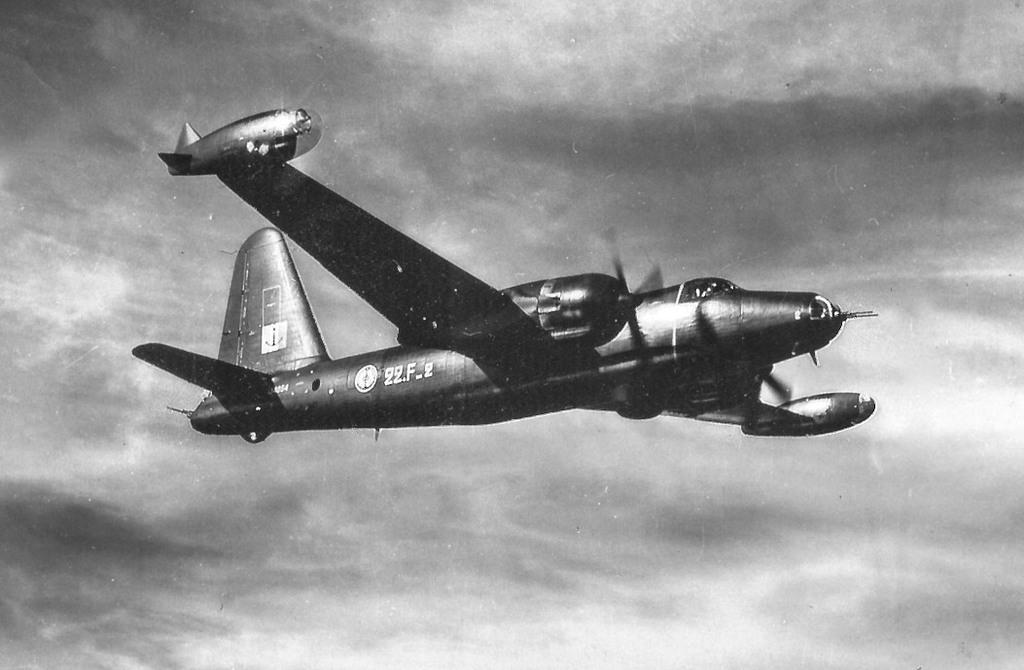What is the color of the aircraft in the image? The aircraft in the image is black. Are there any markings or identifiers on the aircraft? Yes, there are numbers written on the aircraft. What is the color scheme of the entire image? The image is black and white in color. What type of crate is being used to transport the crook in the image? There is no crate or crook present in the image; it features a black color aircraft with numbers written on it. 